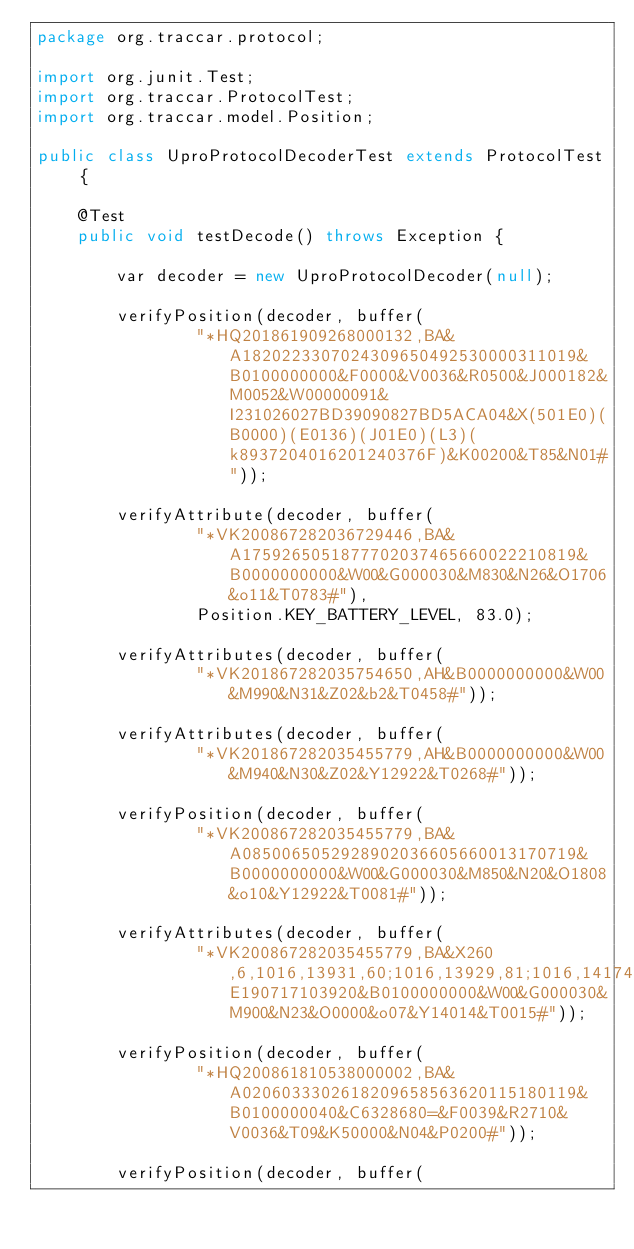Convert code to text. <code><loc_0><loc_0><loc_500><loc_500><_Java_>package org.traccar.protocol;

import org.junit.Test;
import org.traccar.ProtocolTest;
import org.traccar.model.Position;

public class UproProtocolDecoderTest extends ProtocolTest {

    @Test
    public void testDecode() throws Exception {

        var decoder = new UproProtocolDecoder(null);

        verifyPosition(decoder, buffer(
                "*HQ201861909268000132,BA&A1820223307024309650492530000311019&B0100000000&F0000&V0036&R0500&J000182&M0052&W00000091&I231026027BD39090827BD5ACA04&X(501E0)(B0000)(E0136)(J01E0)(L3)(k8937204016201240376F)&K00200&T85&N01#"));

        verifyAttribute(decoder, buffer(
                "*VK200867282036729446,BA&A1759265051877702037465660022210819&B0000000000&W00&G000030&M830&N26&O1706&o11&T0783#"),
                Position.KEY_BATTERY_LEVEL, 83.0);

        verifyAttributes(decoder, buffer(
                "*VK201867282035754650,AH&B0000000000&W00&M990&N31&Z02&b2&T0458#"));

        verifyAttributes(decoder, buffer(
                "*VK201867282035455779,AH&B0000000000&W00&M940&N30&Z02&Y12922&T0268#"));

        verifyPosition(decoder, buffer(
                "*VK200867282035455779,BA&A0850065052928902036605660013170719&B0000000000&W00&G000030&M850&N20&O1808&o10&Y12922&T0081#"));

        verifyAttributes(decoder, buffer(
                "*VK200867282035455779,BA&X260,6,1016,13931,60;1016,13929,81;1016,14174,82;1016,13930,82&E190717103920&B0100000000&W00&G000030&M900&N23&O0000&o07&Y14014&T0015#"));

        verifyPosition(decoder, buffer(
                "*HQ200861810538000002,BA&A0206033302618209658563620115180119&B0100000040&C6328680=&F0039&R2710&V0036&T09&K50000&N04&P0200#"));

        verifyPosition(decoder, buffer(</code> 